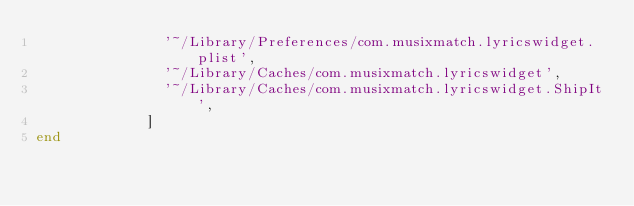<code> <loc_0><loc_0><loc_500><loc_500><_Ruby_>               '~/Library/Preferences/com.musixmatch.lyricswidget.plist',
               '~/Library/Caches/com.musixmatch.lyricswidget',
               '~/Library/Caches/com.musixmatch.lyricswidget.ShipIt',
             ]
end
</code> 